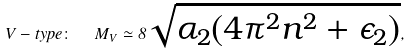Convert formula to latex. <formula><loc_0><loc_0><loc_500><loc_500>V - t y p e \colon \ \ M _ { V } \simeq 8 \sqrt { \alpha _ { 2 } ( 4 \pi ^ { 2 } n ^ { 2 } + \epsilon _ { 2 } ) } ,</formula> 